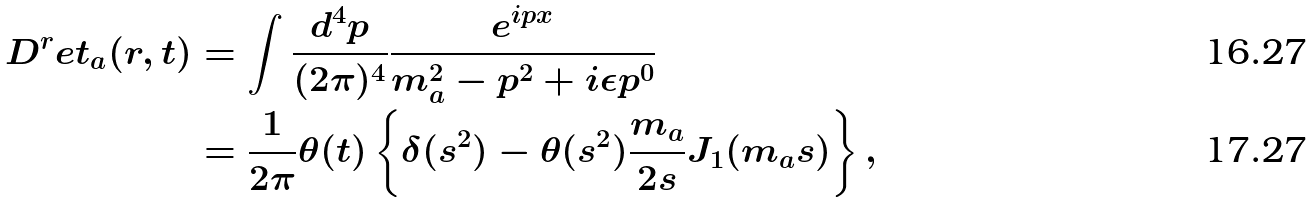<formula> <loc_0><loc_0><loc_500><loc_500>D ^ { r } e t _ { a } ( r , t ) & = \int \frac { d ^ { 4 } p } { ( 2 \pi ) ^ { 4 } } \frac { e ^ { i p x } } { m _ { a } ^ { 2 } - p ^ { 2 } + i \epsilon p ^ { 0 } } \\ & = \frac { 1 } { 2 \pi } \theta ( t ) \left \{ \delta ( s ^ { 2 } ) - \theta ( s ^ { 2 } ) \frac { m _ { a } } { 2 s } J _ { 1 } ( m _ { a } s ) \right \} ,</formula> 